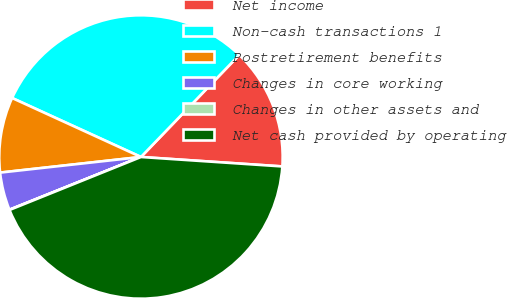Convert chart to OTSL. <chart><loc_0><loc_0><loc_500><loc_500><pie_chart><fcel>Net income<fcel>Non-cash transactions 1<fcel>Postretirement benefits<fcel>Changes in core working<fcel>Changes in other assets and<fcel>Net cash provided by operating<nl><fcel>13.86%<fcel>30.37%<fcel>8.59%<fcel>4.31%<fcel>0.03%<fcel>42.84%<nl></chart> 